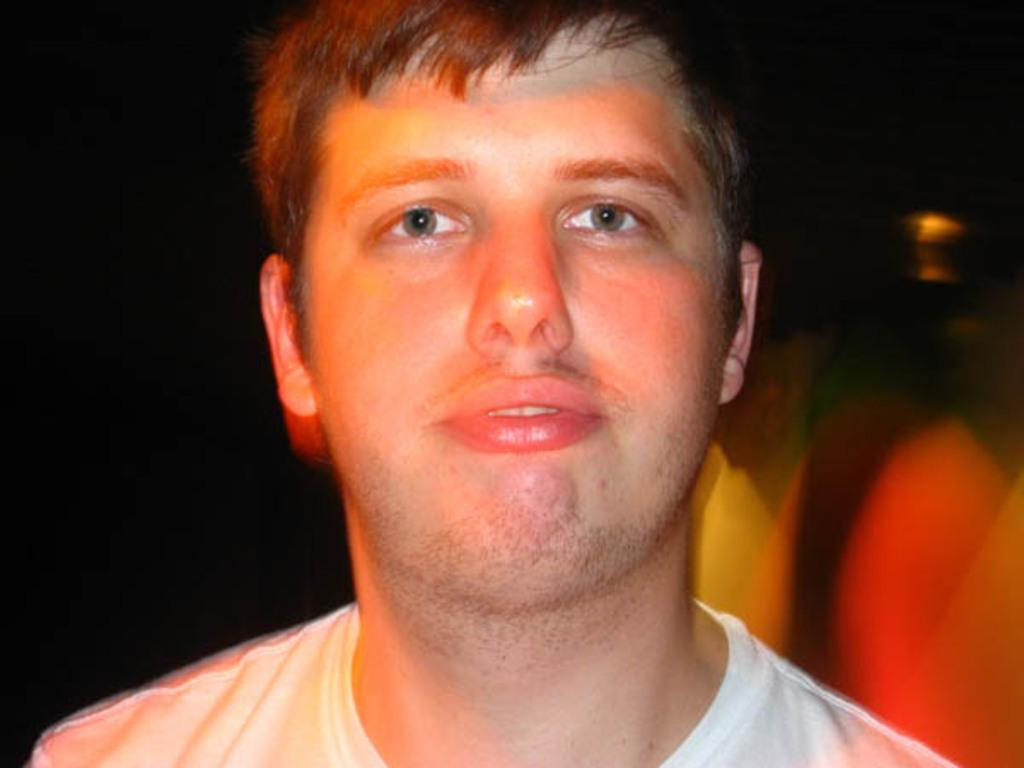Who is the main subject in the image? There is a man in the image. What is the man wearing? The man is wearing a white shirt. Where are the other people in the image located? There is a group of people on the right side of the image. What is the color of the background in the image? The background of the image appears to be black. What type of weather can be seen in the image? There is no indication of weather in the image, as it is focused on the man and the group of people. 